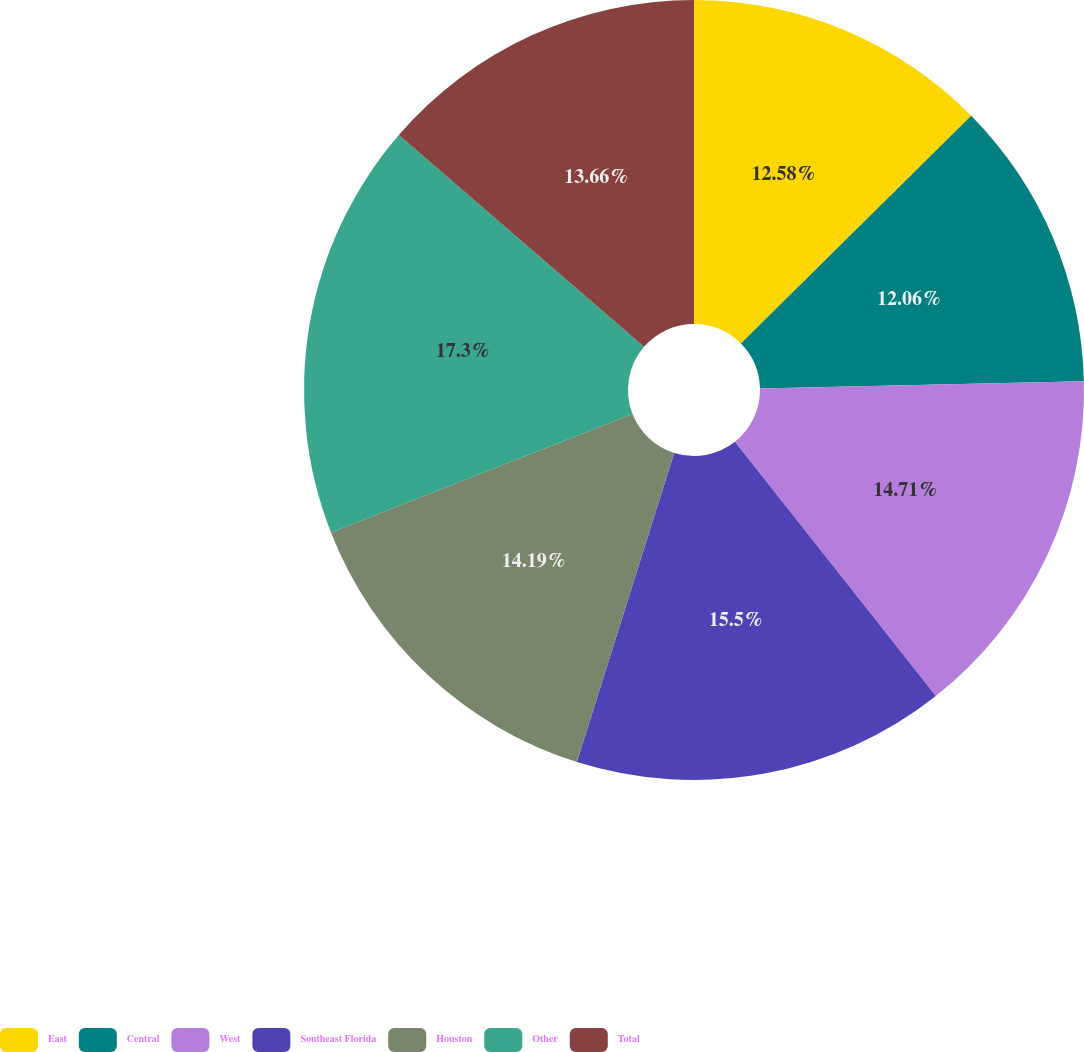Convert chart. <chart><loc_0><loc_0><loc_500><loc_500><pie_chart><fcel>East<fcel>Central<fcel>West<fcel>Southeast Florida<fcel>Houston<fcel>Other<fcel>Total<nl><fcel>12.58%<fcel>12.06%<fcel>14.71%<fcel>15.5%<fcel>14.19%<fcel>17.29%<fcel>13.66%<nl></chart> 